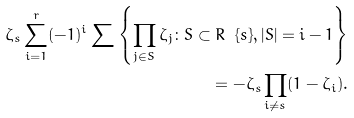<formula> <loc_0><loc_0><loc_500><loc_500>\zeta _ { s } \sum _ { i = 1 } ^ { r } ( - 1 ) ^ { i } \sum \left \{ \prod _ { j \in S } \zeta _ { j } \colon S \subset R \ \{ s \} , | S | = i - 1 \right \} \\ = - \zeta _ { s } \prod _ { i \neq s } ( 1 - \zeta _ { i } ) .</formula> 